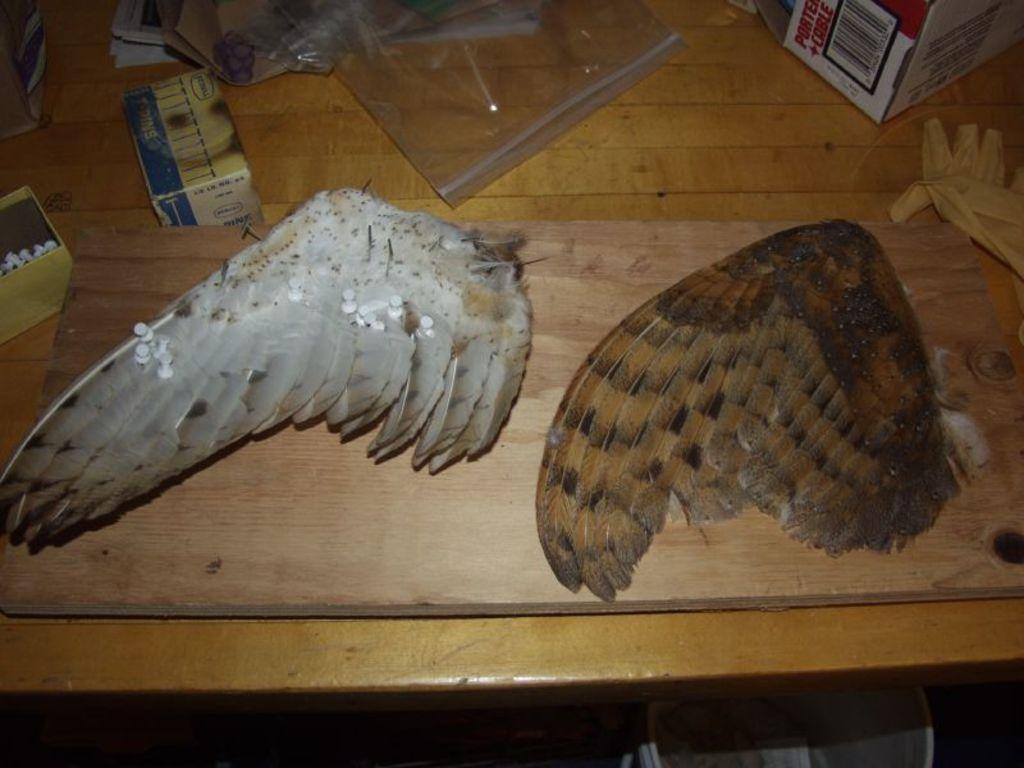Describe this image in one or two sentences. Here we can see two wings of two animals on a wooden board on the table. We can also see papers,a box on the right side and two other boxes on the left side,cover,glove on the right side and some other objects on the table. 